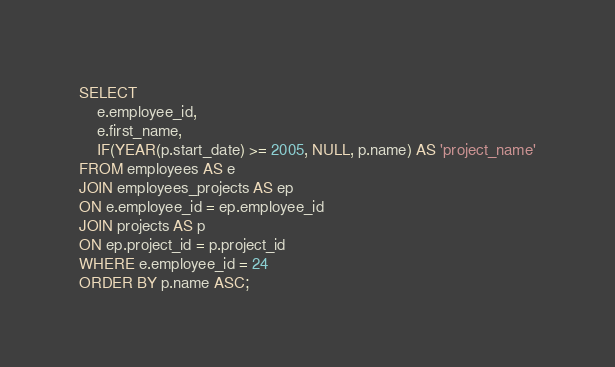Convert code to text. <code><loc_0><loc_0><loc_500><loc_500><_SQL_>SELECT
	e.employee_id,
    e.first_name,
    IF(YEAR(p.start_date) >= 2005, NULL, p.name) AS 'project_name'
FROM employees AS e
JOIN employees_projects AS ep
ON e.employee_id = ep.employee_id
JOIN projects AS p
ON ep.project_id = p.project_id
WHERE e.employee_id = 24
ORDER BY p.name ASC;</code> 